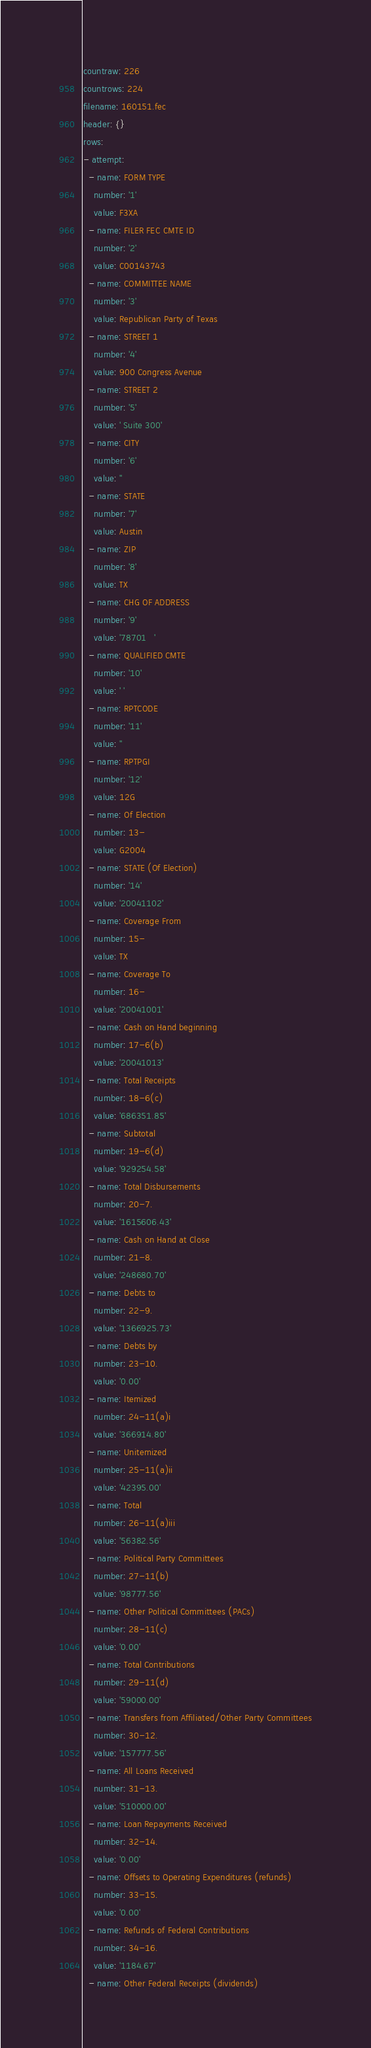Convert code to text. <code><loc_0><loc_0><loc_500><loc_500><_YAML_>countraw: 226
countrows: 224
filename: 160151.fec
header: {}
rows:
- attempt:
  - name: FORM TYPE
    number: '1'
    value: F3XA
  - name: FILER FEC CMTE ID
    number: '2'
    value: C00143743
  - name: COMMITTEE NAME
    number: '3'
    value: Republican Party of Texas
  - name: STREET 1
    number: '4'
    value: 900 Congress Avenue
  - name: STREET 2
    number: '5'
    value: ' Suite 300'
  - name: CITY
    number: '6'
    value: ''
  - name: STATE
    number: '7'
    value: Austin
  - name: ZIP
    number: '8'
    value: TX
  - name: CHG OF ADDRESS
    number: '9'
    value: '78701   '
  - name: QUALIFIED CMTE
    number: '10'
    value: ' '
  - name: RPTCODE
    number: '11'
    value: ''
  - name: RPTPGI
    number: '12'
    value: 12G
  - name: Of Election
    number: 13-
    value: G2004
  - name: STATE (Of Election)
    number: '14'
    value: '20041102'
  - name: Coverage From
    number: 15-
    value: TX
  - name: Coverage To
    number: 16-
    value: '20041001'
  - name: Cash on Hand beginning
    number: 17-6(b)
    value: '20041013'
  - name: Total Receipts
    number: 18-6(c)
    value: '686351.85'
  - name: Subtotal
    number: 19-6(d)
    value: '929254.58'
  - name: Total Disbursements
    number: 20-7.
    value: '1615606.43'
  - name: Cash on Hand at Close
    number: 21-8.
    value: '248680.70'
  - name: Debts to
    number: 22-9.
    value: '1366925.73'
  - name: Debts by
    number: 23-10.
    value: '0.00'
  - name: Itemized
    number: 24-11(a)i
    value: '366914.80'
  - name: Unitemized
    number: 25-11(a)ii
    value: '42395.00'
  - name: Total
    number: 26-11(a)iii
    value: '56382.56'
  - name: Political Party Committees
    number: 27-11(b)
    value: '98777.56'
  - name: Other Political Committees (PACs)
    number: 28-11(c)
    value: '0.00'
  - name: Total Contributions
    number: 29-11(d)
    value: '59000.00'
  - name: Transfers from Affiliated/Other Party Committees
    number: 30-12.
    value: '157777.56'
  - name: All Loans Received
    number: 31-13.
    value: '510000.00'
  - name: Loan Repayments Received
    number: 32-14.
    value: '0.00'
  - name: Offsets to Operating Expenditures (refunds)
    number: 33-15.
    value: '0.00'
  - name: Refunds of Federal Contributions
    number: 34-16.
    value: '1184.67'
  - name: Other Federal Receipts (dividends)</code> 